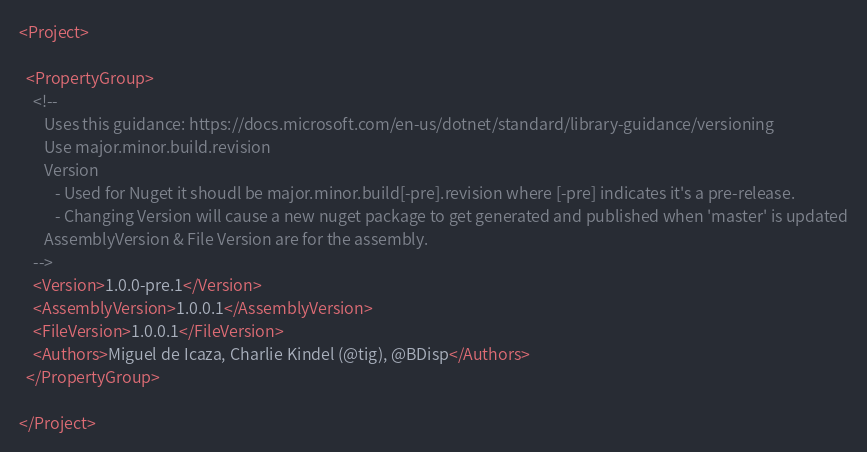Convert code to text. <code><loc_0><loc_0><loc_500><loc_500><_XML_><Project>

  <PropertyGroup>
    <!--
       Uses this guidance: https://docs.microsoft.com/en-us/dotnet/standard/library-guidance/versioning
       Use major.minor.build.revision
       Version 
          - Used for Nuget it shoudl be major.minor.build[-pre].revision where [-pre] indicates it's a pre-release.
          - Changing Version will cause a new nuget package to get generated and published when 'master' is updated
       AssemblyVersion & File Version are for the assembly. 
    -->
    <Version>1.0.0-pre.1</Version>
    <AssemblyVersion>1.0.0.1</AssemblyVersion>
    <FileVersion>1.0.0.1</FileVersion>    
    <Authors>Miguel de Icaza, Charlie Kindel (@tig), @BDisp</Authors>
  </PropertyGroup>

</Project></code> 